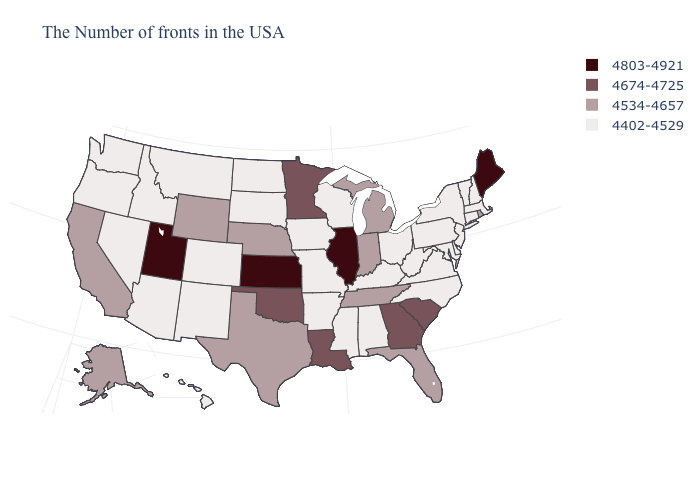Which states have the lowest value in the South?
Short answer required. Delaware, Maryland, Virginia, North Carolina, West Virginia, Kentucky, Alabama, Mississippi, Arkansas. Among the states that border Nevada , does Utah have the highest value?
Answer briefly. Yes. What is the highest value in the USA?
Concise answer only. 4803-4921. Name the states that have a value in the range 4674-4725?
Keep it brief. South Carolina, Georgia, Louisiana, Minnesota, Oklahoma. Name the states that have a value in the range 4402-4529?
Short answer required. Massachusetts, New Hampshire, Vermont, Connecticut, New York, New Jersey, Delaware, Maryland, Pennsylvania, Virginia, North Carolina, West Virginia, Ohio, Kentucky, Alabama, Wisconsin, Mississippi, Missouri, Arkansas, Iowa, South Dakota, North Dakota, Colorado, New Mexico, Montana, Arizona, Idaho, Nevada, Washington, Oregon, Hawaii. What is the lowest value in the USA?
Write a very short answer. 4402-4529. Does the map have missing data?
Give a very brief answer. No. Which states have the highest value in the USA?
Concise answer only. Maine, Illinois, Kansas, Utah. Does the map have missing data?
Short answer required. No. Which states have the lowest value in the USA?
Answer briefly. Massachusetts, New Hampshire, Vermont, Connecticut, New York, New Jersey, Delaware, Maryland, Pennsylvania, Virginia, North Carolina, West Virginia, Ohio, Kentucky, Alabama, Wisconsin, Mississippi, Missouri, Arkansas, Iowa, South Dakota, North Dakota, Colorado, New Mexico, Montana, Arizona, Idaho, Nevada, Washington, Oregon, Hawaii. Which states have the highest value in the USA?
Keep it brief. Maine, Illinois, Kansas, Utah. What is the value of California?
Short answer required. 4534-4657. Does Connecticut have the lowest value in the USA?
Give a very brief answer. Yes. How many symbols are there in the legend?
Keep it brief. 4. What is the highest value in states that border Virginia?
Give a very brief answer. 4534-4657. 